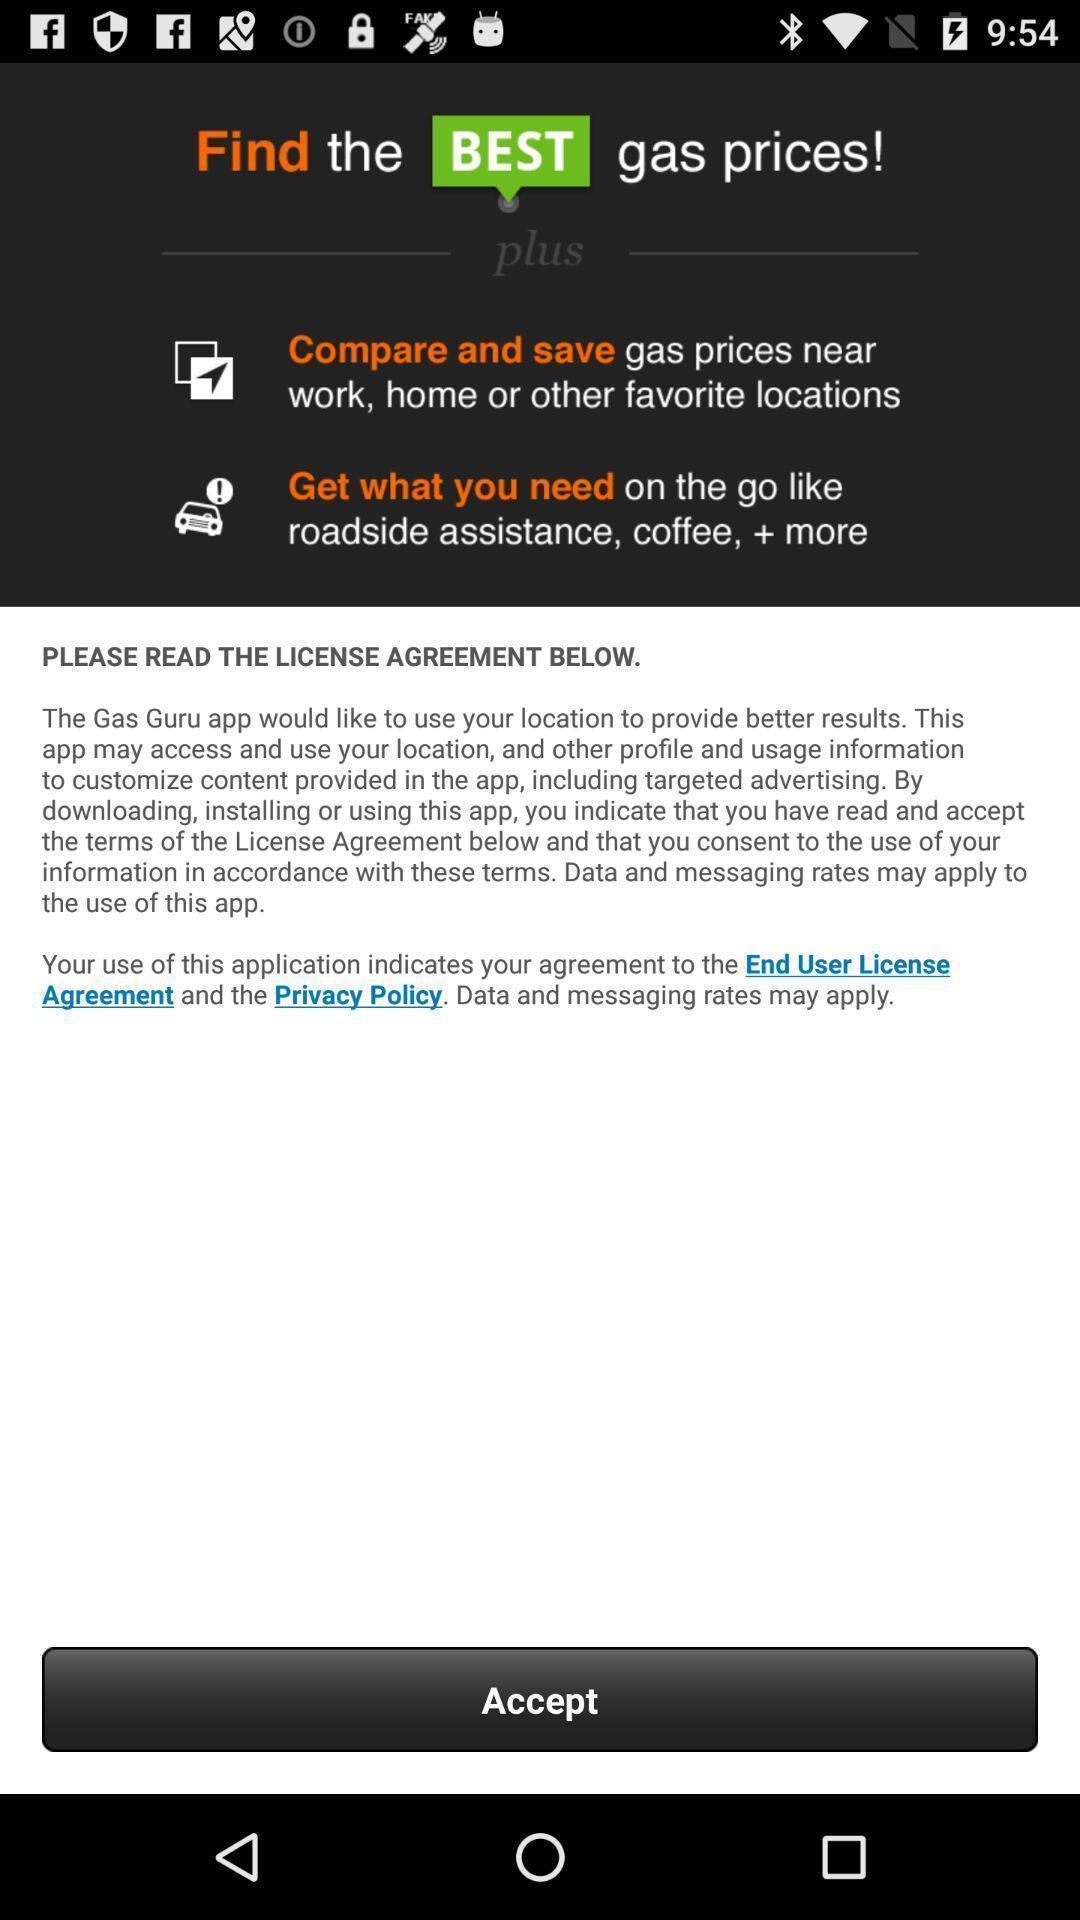Summarize the main components in this picture. Screen displaying the accept option. 